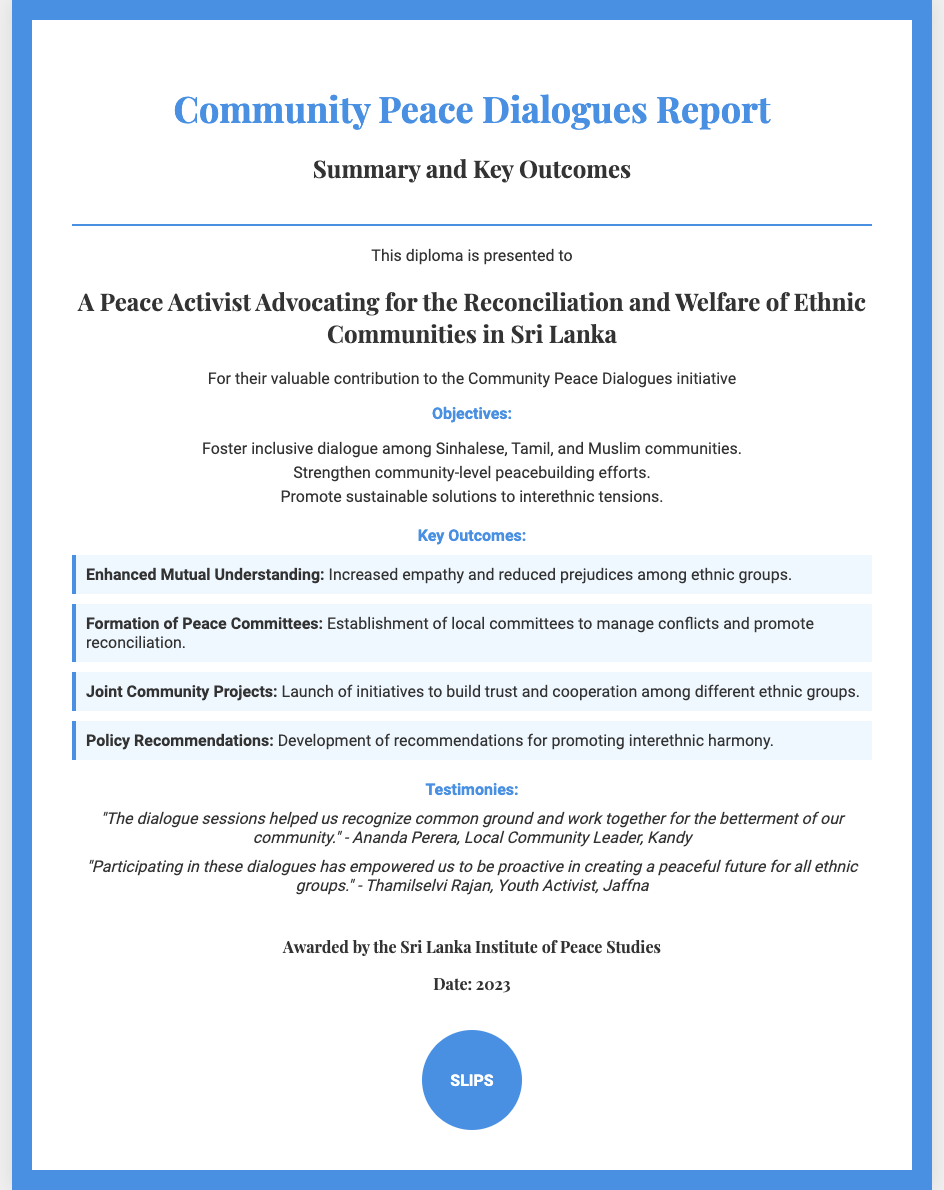What is the title of the document? The title is prominently displayed at the top of the document, which is "Community Peace Dialogues Report".
Answer: Community Peace Dialogues Report Who is the diploma presented to? The diploma specifically mentions the recipient, stating it is presented to "A Peace Activist Advocating for the Reconciliation and Welfare of Ethnic Communities in Sri Lanka".
Answer: A Peace Activist Advocating for the Reconciliation and Welfare of Ethnic Communities in Sri Lanka What organization awarded the diploma? The awarding organization is indicated at the bottom of the document, mentioned as "Sri Lanka Institute of Peace Studies".
Answer: Sri Lanka Institute of Peace Studies What year was the diploma awarded? The date on the diploma indicates the year it was awarded as 2023.
Answer: 2023 How many key outcomes are listed in the document? The document enumerates four key outcomes under the section "Key Outcomes".
Answer: Four What is one of the objectives of the Community Peace Dialogues? The objectives outlined in the document include multiple points; one objective stated is to "Foster inclusive dialogue among Sinhalese, Tamil, and Muslim communities."
Answer: Foster inclusive dialogue among Sinhalese, Tamil, and Muslim communities What is a testimony mentioned in the document? A testimony is quoted in the document, such as "The dialogue sessions helped us recognize common ground and work together for the betterment of our community."
Answer: The dialogue sessions helped us recognize common ground and work together for the betterment of our community What color is used for the diploma's border? The color indicated for the border of the diploma is "blue", more specifically represented by the hexadecimal color #4a90e2.
Answer: Blue What type of projects were launched according to the key outcomes? The key outcomes mention the launch of "Joint Community Projects" to build trust and cooperation.
Answer: Joint Community Projects 